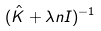<formula> <loc_0><loc_0><loc_500><loc_500>( \hat { K } + \lambda n I ) ^ { - 1 }</formula> 